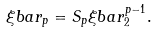Convert formula to latex. <formula><loc_0><loc_0><loc_500><loc_500>\xi b a r _ { p } = S _ { p } \xi b a r _ { 2 } ^ { p - 1 } .</formula> 